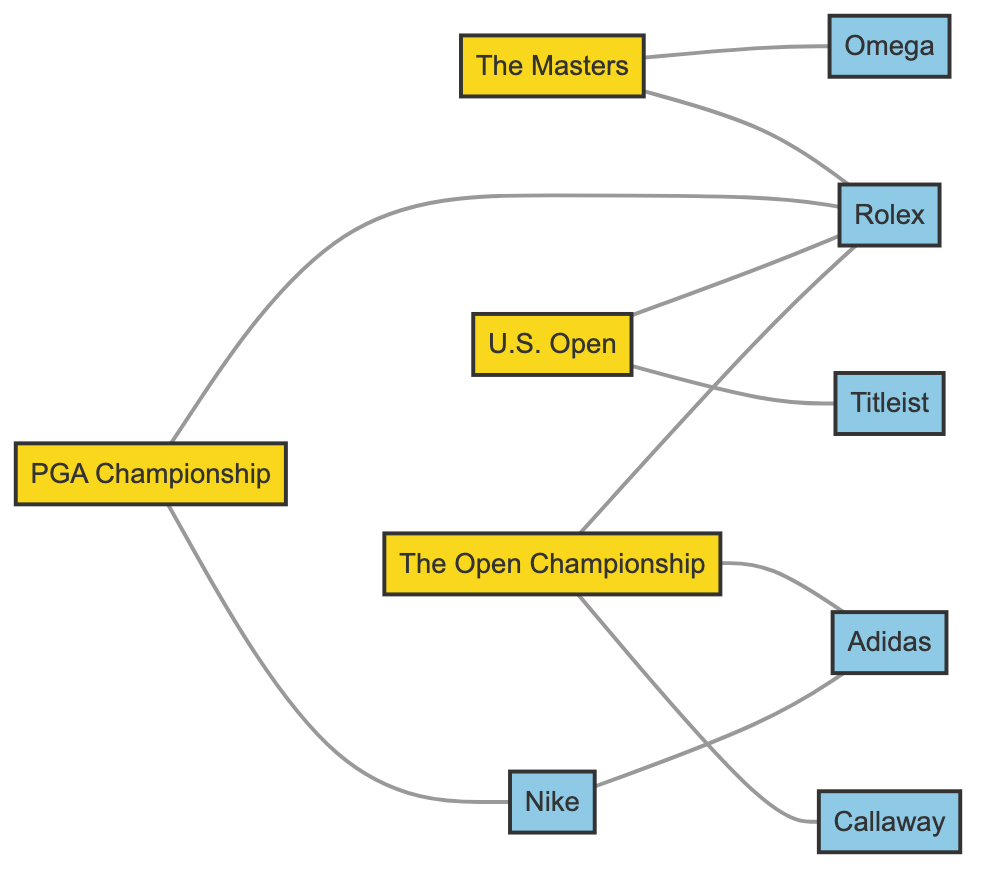What brands are connected to The Masters? By examining the connections from the node "The Masters", we find edges leading to "Rolex" and "Omega". Therefore, the brands connected to "The Masters" are those two.
Answer: Rolex, Omega How many tournaments are sponsors for? The diagram shows four tournament nodes: "The Masters", "PGA Championship", "U.S. Open", and "The Open Championship". Each of these is a separate entity, thus the count of tournament sponsors is four.
Answer: 4 Which brand is connected to both the PGA Championship and the U.S. Open? We start by identifying the edges leading from "PGA Championship" and "U.S. Open". "Rolex" connects to both tournaments as shown in the edges. Hence, the brand that connects both is "Rolex".
Answer: Rolex What is the total number of edges in the graph? Counting the connections (or edges) between nodes, we can see there are a total of 10 edges connecting different tournament and brand nodes in the graph.
Answer: 10 Which tournament is sponsored by Titleist? Looking for connections from the "U.S. Open" node, we see an edge leading to "Titleist". Thus, "Titleist" is a sponsor for the "U.S. Open".
Answer: U.S. Open Which two brands are connected to The Open Championship? Reviewing the connections from "The Open Championship", we see edges leading to "Callaway", "Rolex", and "Adidas". We need only the two, so we select "Callaway" and "Rolex".
Answer: Callaway, Rolex How many brands are connected to the tournament nodes? Analyzing the edges, there are 5 unique brands: "Nike", "Rolex", "Titleist", "Callaway", "Adidas", and "Omega". Therefore, there are five unique brands connected to all tournament nodes combined.
Answer: 6 Which brand is connected to Nike? To find the connection, we look for edges stemming from the node "Nike", which directly connects to "Adidas". Thus, "Adidas" is the brand that connects to "Nike".
Answer: Adidas Which tournament has the highest number of sponsors? Looking at the edges connected to each tournament, "The Open Championship" has three sponsors: "Callaway", "Rolex", and "Adidas". Thus, it has the highest number of sponsor connections.
Answer: The Open Championship 